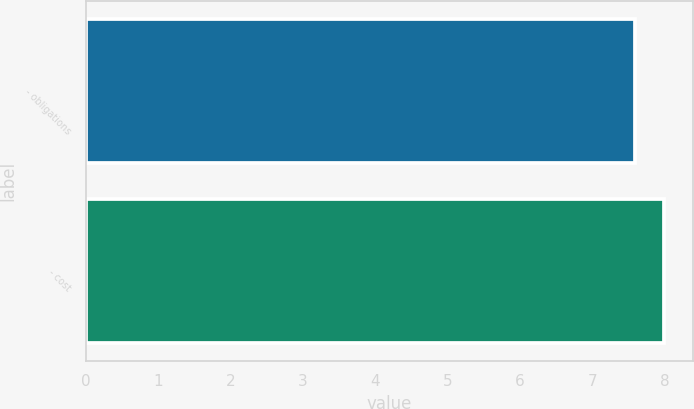Convert chart to OTSL. <chart><loc_0><loc_0><loc_500><loc_500><bar_chart><fcel>- obligations<fcel>- cost<nl><fcel>7.6<fcel>8<nl></chart> 